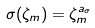<formula> <loc_0><loc_0><loc_500><loc_500>\sigma ( \zeta _ { m } ) = \zeta _ { m } ^ { a _ { \sigma } }</formula> 